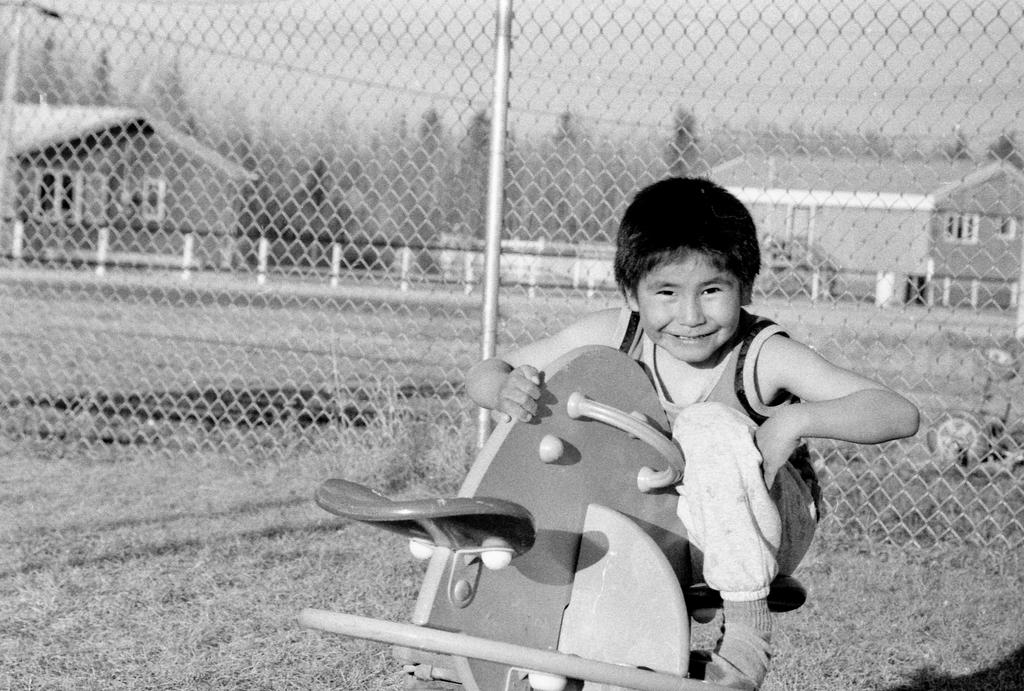What is the kid holding in the image? There is a kid holding an object in the image. What can be seen in the background of the image? There is a fence, houses, and trees in the background of the image. What type of vein is visible on the kid's forehead in the image? There is no vein visible on the kid's forehead in the image. How much honey is being consumed by the kid in the image? There is no honey present in the image, so it cannot be determined how much the kid might be consuming. 